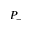<formula> <loc_0><loc_0><loc_500><loc_500>P _ { - }</formula> 